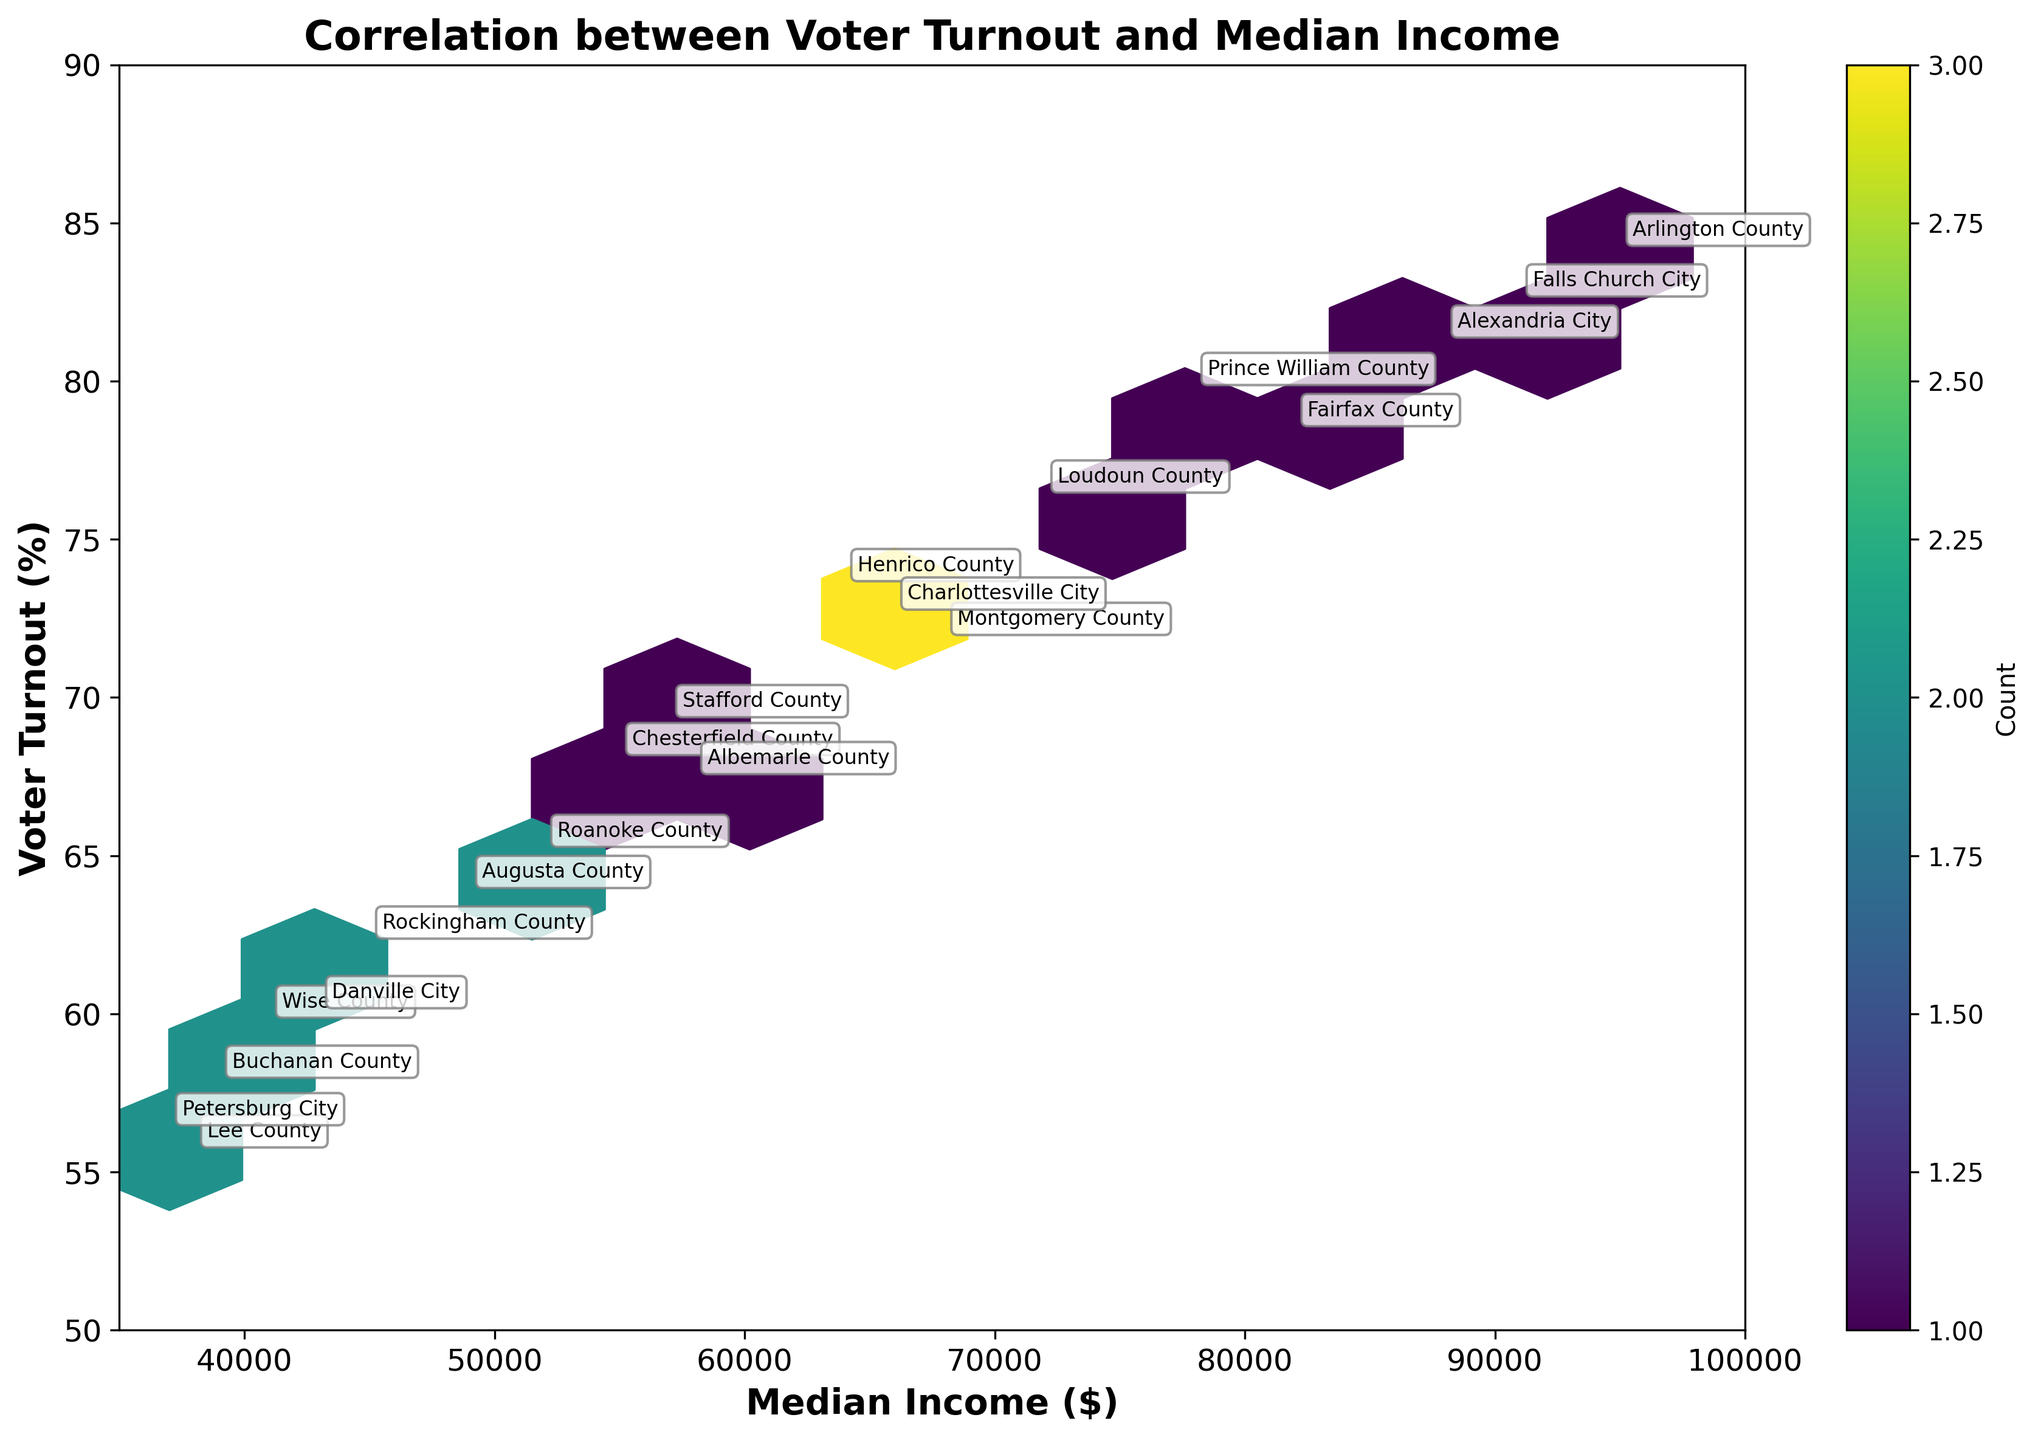What is the title of the hexbin plot? The title is displayed at the top of the plot, indicating the overall theme or subject of the visualization.
Answer: Correlation between Voter Turnout and Median Income What are the x-axis and y-axis labels? The labels for the x-axis and y-axis are displayed along the bottom and left sides of the plot, respectively, to denote what each axis represents.
Answer: Median Income ($) and Voter Turnout (%) Which county has the highest voter turnout? By looking at the annotated points on the plot, you can identify the one with the highest y-axis value. Arlington County is located at the highest y value.
Answer: Arlington County Which county has the lowest median income? By identifying the annotated point with the lowest x-axis value on the hexbin plot, you can determine the county with the lowest median income.
Answer: Lee County Are counties with higher median incomes generally associated with higher voter turnout? By examining the overall distribution and density of hexagons in the upper right part of the figure, one can determine if a positive correlation is evident.
Answer: Yes What is the median income and voter turnout for Falls Church City? Locate Falls Church City on the plot through annotation; read the x and y values at that point.
Answer: $91,000 and 82.6% What is the common range of voter turnout for counties with a median income between $40,000 and $50,000? By examining the hexagon distribution between x-values of $40,000 and $50,000, the corresponding y-values or range of voter turnout can be inferred.
Answer: 55% to 65% What pattern do you observe between median income and voter turnout in this plot? Reviewing the spread and intensity of hexagons, one can describe the overall trend. Denser hexagons in the upper right indicate that increased income tends to correlate with higher voter turnout.
Answer: Positive correlation Which two counties have the closest voter turnout percentages but different median incomes? By comparing annotated points with similar y-values but different x-values, the closest matches can be identified. For instance, Loudoun County and Prince William County both have similar voter turnouts around 76% and 79.8% respectively but different median incomes at $72,000 and $78,000.
Answer: Loudoun County and Prince William County How many counties show a voter turnout of at least 80%? By counting the unique annotations above the 80% mark on the y-axis, the number of counties can be determined. Here, Arlington County, Falls Church City, and Alexandria City fit this criterion.
Answer: Three 